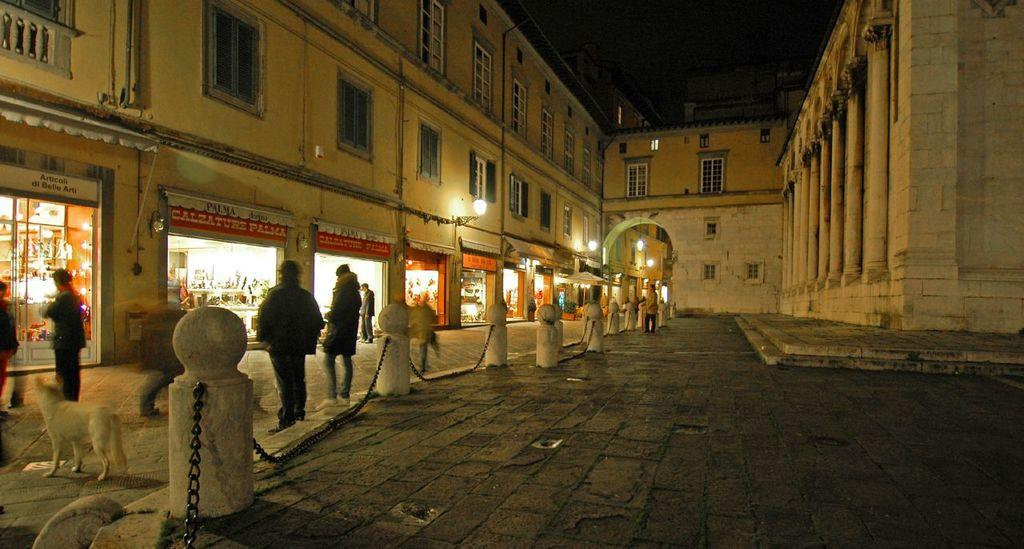Provide a one-sentence caption for the provided image. Several people standing outside a Calzature pizza store at nighttime. 